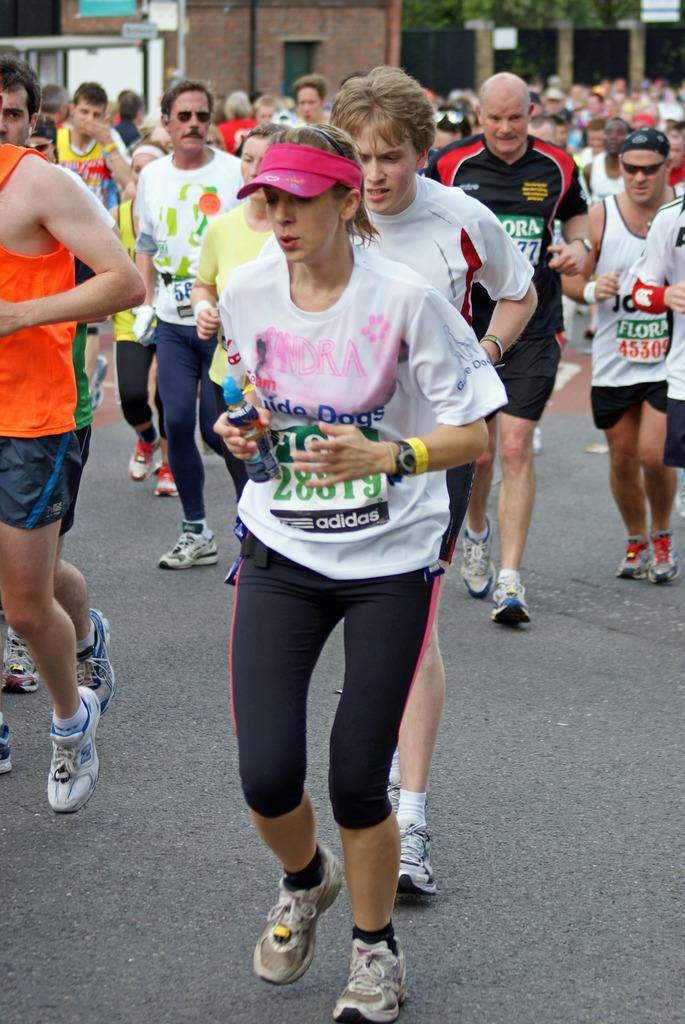What are the people in the image doing? The people in the image are running on the road. What can be seen in the background of the image? There are buildings and trees visible in the image. What accessories are some people wearing in the image? Some people are wearing sunglasses in the image. What is the woman in the image wearing on her head? The woman in the image is wearing a cap. What time of day is it in the image, and how does the need for balance affect the runners? The provided facts do not mention the time of day, and there is no indication of the need for balance affecting the runners in the image. 